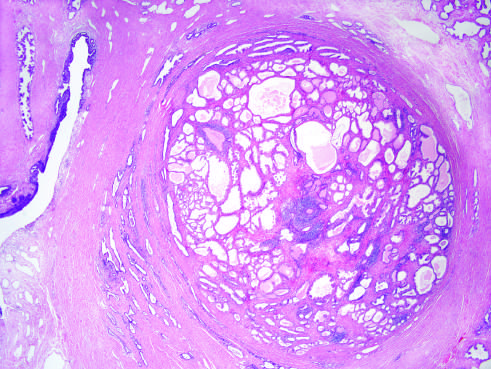what is the nodularity caused by?
Answer the question using a single word or phrase. Stromal 